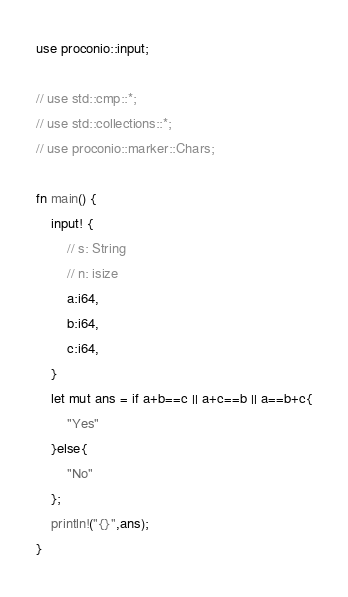<code> <loc_0><loc_0><loc_500><loc_500><_Rust_>use proconio::input;

// use std::cmp::*;
// use std::collections::*;
// use proconio::marker::Chars;

fn main() {
    input! {
        // s: String
        // n: isize
        a:i64,
        b:i64,
        c:i64,
    }
    let mut ans = if a+b==c || a+c==b || a==b+c{
        "Yes"
    }else{
        "No"
    };
    println!("{}",ans);
}
</code> 